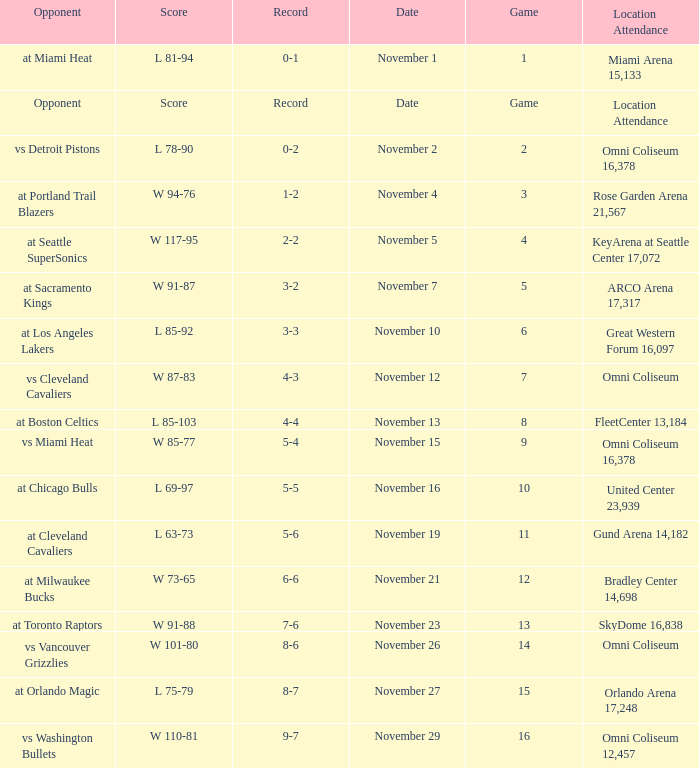Could you parse the entire table? {'header': ['Opponent', 'Score', 'Record', 'Date', 'Game', 'Location Attendance'], 'rows': [['at Miami Heat', 'L 81-94', '0-1', 'November 1', '1', 'Miami Arena 15,133'], ['Opponent', 'Score', 'Record', 'Date', 'Game', 'Location Attendance'], ['vs Detroit Pistons', 'L 78-90', '0-2', 'November 2', '2', 'Omni Coliseum 16,378'], ['at Portland Trail Blazers', 'W 94-76', '1-2', 'November 4', '3', 'Rose Garden Arena 21,567'], ['at Seattle SuperSonics', 'W 117-95', '2-2', 'November 5', '4', 'KeyArena at Seattle Center 17,072'], ['at Sacramento Kings', 'W 91-87', '3-2', 'November 7', '5', 'ARCO Arena 17,317'], ['at Los Angeles Lakers', 'L 85-92', '3-3', 'November 10', '6', 'Great Western Forum 16,097'], ['vs Cleveland Cavaliers', 'W 87-83', '4-3', 'November 12', '7', 'Omni Coliseum'], ['at Boston Celtics', 'L 85-103', '4-4', 'November 13', '8', 'FleetCenter 13,184'], ['vs Miami Heat', 'W 85-77', '5-4', 'November 15', '9', 'Omni Coliseum 16,378'], ['at Chicago Bulls', 'L 69-97', '5-5', 'November 16', '10', 'United Center 23,939'], ['at Cleveland Cavaliers', 'L 63-73', '5-6', 'November 19', '11', 'Gund Arena 14,182'], ['at Milwaukee Bucks', 'W 73-65', '6-6', 'November 21', '12', 'Bradley Center 14,698'], ['at Toronto Raptors', 'W 91-88', '7-6', 'November 23', '13', 'SkyDome 16,838'], ['vs Vancouver Grizzlies', 'W 101-80', '8-6', 'November 26', '14', 'Omni Coliseum'], ['at Orlando Magic', 'L 75-79', '8-7', 'November 27', '15', 'Orlando Arena 17,248'], ['vs Washington Bullets', 'W 110-81', '9-7', 'November 29', '16', 'Omni Coliseum 12,457']]} Who was their opponent in game 4? At seattle supersonics. 